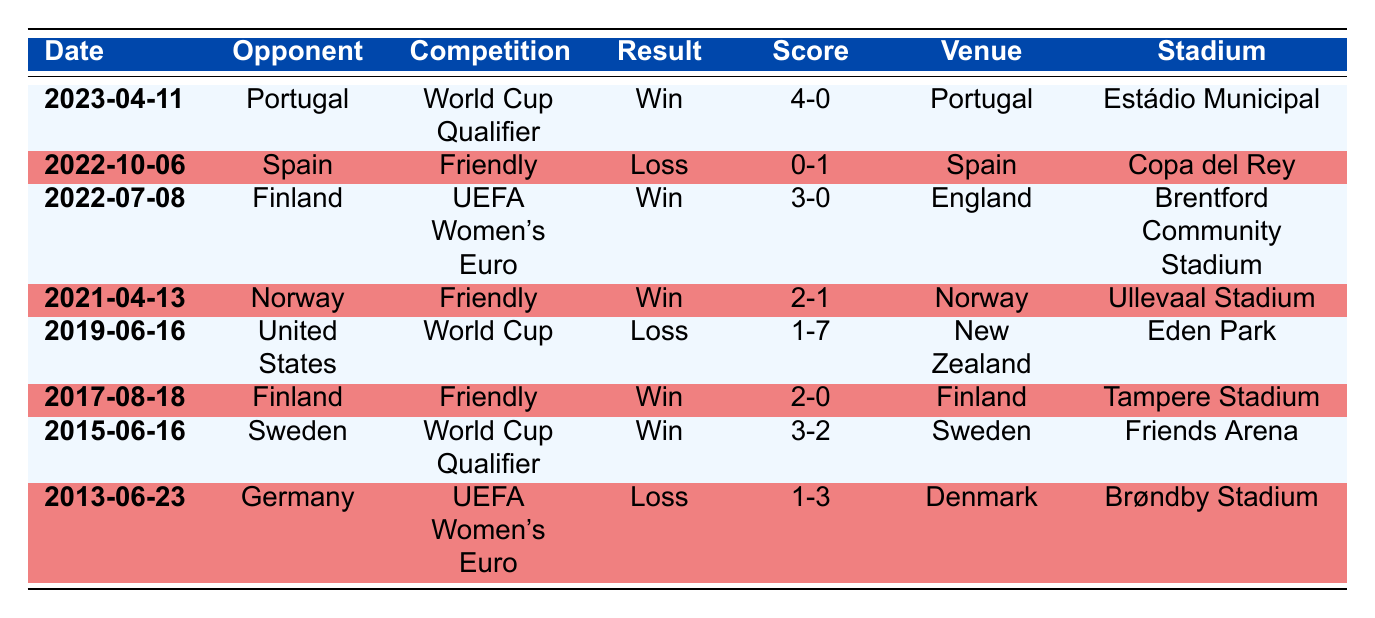What was the most recent match played by Denmark's women's national team? The most recent match is listed first in the table, dated 2023-04-11, against Portugal.
Answer: 2023-04-11 How many matches did Denmark win in the last decade? By counting the rows with "Win" in the result column, there are 4 wins: against Sweden, Finland (twice), and Portugal.
Answer: 4 What was the score when Denmark played against the United States? The row for the match against the United States indicates that Denmark scored 1 goal and conceded 7; therefore, the score was 1-7.
Answer: 1-7 Did Denmark score more goals against Finland in 2022 or 2017? The match in 2022 shows Denmark scoring 3 goals while in 2017 they scored 2 goals. Therefore, Denmark scored more in 2022.
Answer: Yes What was the average number of goals scored by Denmark in their winning matches? In their winning matches, Denmark scored 3 (against Sweden) + 2 (against Finland in 2017) + 2 (against Norway) + 4 (against Portugal) = 11 goals in total. There are 4 wins, so the average is 11/4 = 2.75.
Answer: 2.75 How many matches resulted in a loss by a score of 1-0 or worse? Two losses (against Germany and Spain) had scores of 1-0 or worse, qualifying as a loss by a score margin of one goal or more.
Answer: 2 Which competition had the most wins for Denmark? There are 2 wins in the UEFA Women's Euro (against Finland in 2022 and 1 loss against Germany in 2013), and 2 wins in the World Cup Qualifiers (against Sweden and Portugal), but the most wins are from friendlies. Counting up shows friendlies yield 3 wins against Norway and Finland, making them the most productive.
Answer: Friendlies In which venue did Denmark score the highest number of goals in a match? Denmark scored 4 goals in the match against Portugal at Estádio Municipal, which is the highest number recorded in the table.
Answer: Estádio Municipal 